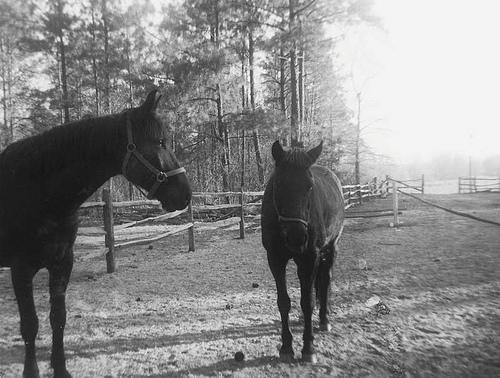Describe the environment where the horses are standing. The horses are in a dirt field within a pen enclosed by a long wooden fence. There is grass, an open gateway, and trees with few leaves at the edge of the fence, along with some tall trees in the distant background. How many horses are in the image, and what are their relative sizes? There are two horses in the image - one larger horse looking away from the camera, and a smaller horse looking towards the camera. Count and describe the horses' unique features in the image. There are numerous features: a horse halter, a horse hoof, a horse forelock, ears of the shorter horse, ears of the larger horse, reigns around the horse's head, left horse's right eye, right horse's two eyes, right horse's hooves, left horse's mane, and right black horse's mane. Analyze the interaction between the two horses and their body language. One horse is looking towards the camera and appears to be watching it, while the other horse is looking away and seems to be more focused on something else in the field or the other horse. What type of photograph is this and what is the main subject? This is a black and white photograph with the main subject being two dark horses on a farm, one looking at the camera and the other looking away. Provide a brief summary of the image, highlighting its main elements and setting. In the black and white photograph, two horses of different sizes are standing in a dirt field enclosed by a wooden fence. There is an open gateway, tall trees with few leaves, and branches in the background, creating a serene and nostalgic atmosphere. What kind of animals are being depicted in the image, and what are they doing? Two horses, one looking towards the camera and the other looking away, are standing in a dirt field. The space is enclosed by a wooden fence with an open gateway, and there are trees in the background. Evaluate the quality of the photograph in terms of clarity, focus, and subject matter. The photograph has clearly captured the subject matter in focus and reveals a diverse range of objects, such as the horses, fence, gateway, and trees. The black and white color scheme adds depth to the image. Provide an emotional description of the image. The black and white photograph evokes a nostalgic and serene atmosphere, showing two beautiful horses peacefully standing in a rural landscape with an open gateway and tall trees. Describe the foreground of the image. Two horses, a dirt field, and a wooden fence What kind of fence surrounds the field the horses are in? Wooden split rail fence Can you find the colorful blooming flowers beside the wooden fence? The image is described as a black and white photograph, which means there are no colors to be identified. Describing colorful flowers is misleading. Is there any feces in the horse pen? Yes, there is feces in the dirt-covered pen What does the field consist of? Grass and dirt What kind of activity is happening in this scene? Horses standing in the field, one observing the camera Which horse is larger? b. The horse on the right Are there any dead trees in the background? Yes, a single dead tree Finish this sentence: The horse to the right is... Looking towards the camera Identify the positions of the two horses. Left horse near the fence, right horse looking towards the camera What is the condition of the trees in the background? Tall with few leaves Describe the background of the image. Trees with few leaves, a fence, and an open gateway How far are the trees in the background from the nearest fence line? Distant Can you see the horse riding equipment such as a saddle on the larger horse? No, it's not mentioned in the image. Do the two horses appear to be walking away from the camera? One of the horses is described as looking towards the camera, and the other is seen looking away. Assuming both are walking away from the camera is misleading. Point out the object that exemplifies an open doorway. The gap in the fence Do the two horses have reigns around their heads? No, only one horse has a horse halter What is the horse on the left doing? Looking away from the camera What emotions does the right horse seem to express? Alertness and curiosity What is between the two horizontal logs? An open gateway Which horse is more attentive to the camera? The horse on the right Provide a brief summary of the scene. Two horses in a dirt field, surrounded by a fence, with trees in the background What type of photograph is this? A black and white photograph 